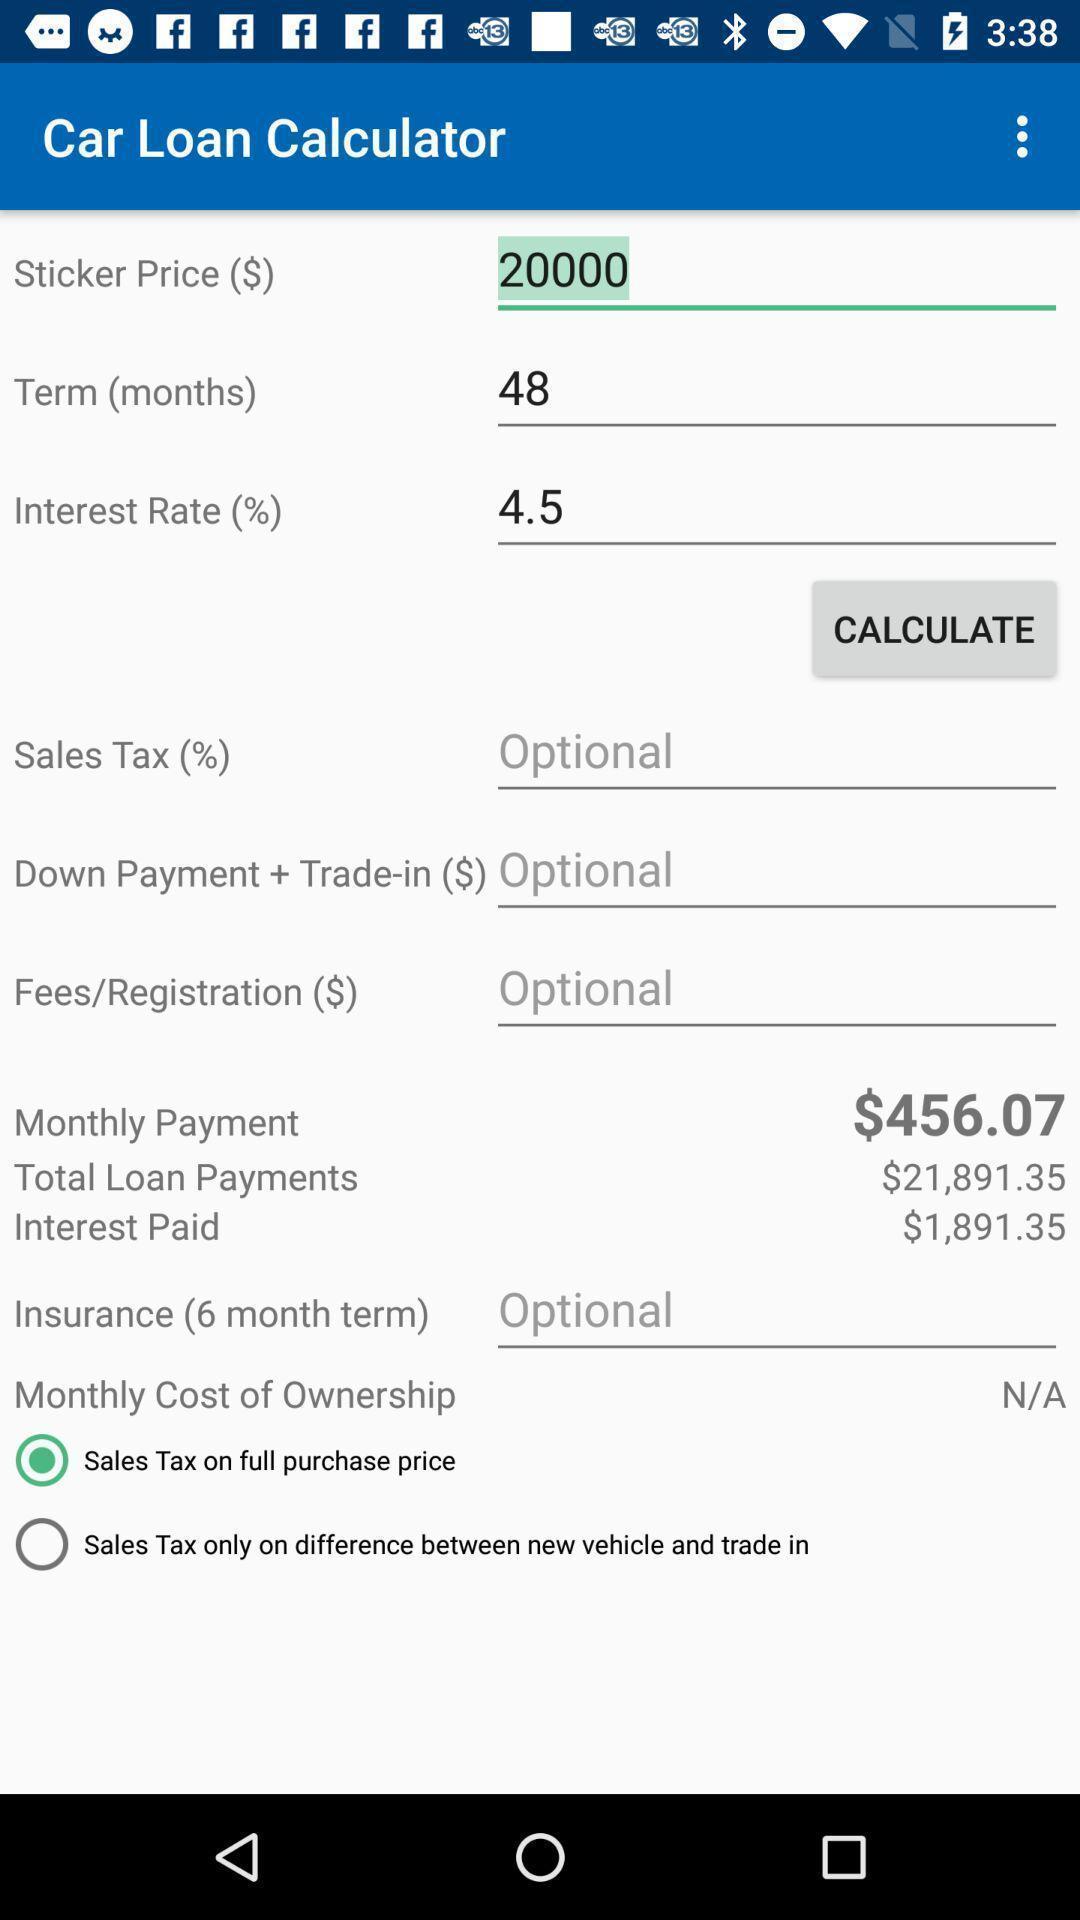What is the overall content of this screenshot? Page showing car loan calculator. 